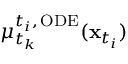<formula> <loc_0><loc_0><loc_500><loc_500>\mu _ { t _ { k } } ^ { t _ { i } , \, O D E } ( x _ { t _ { i } } )</formula> 